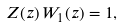<formula> <loc_0><loc_0><loc_500><loc_500>Z ( z ) \, W _ { 1 } ( z ) = 1 ,</formula> 